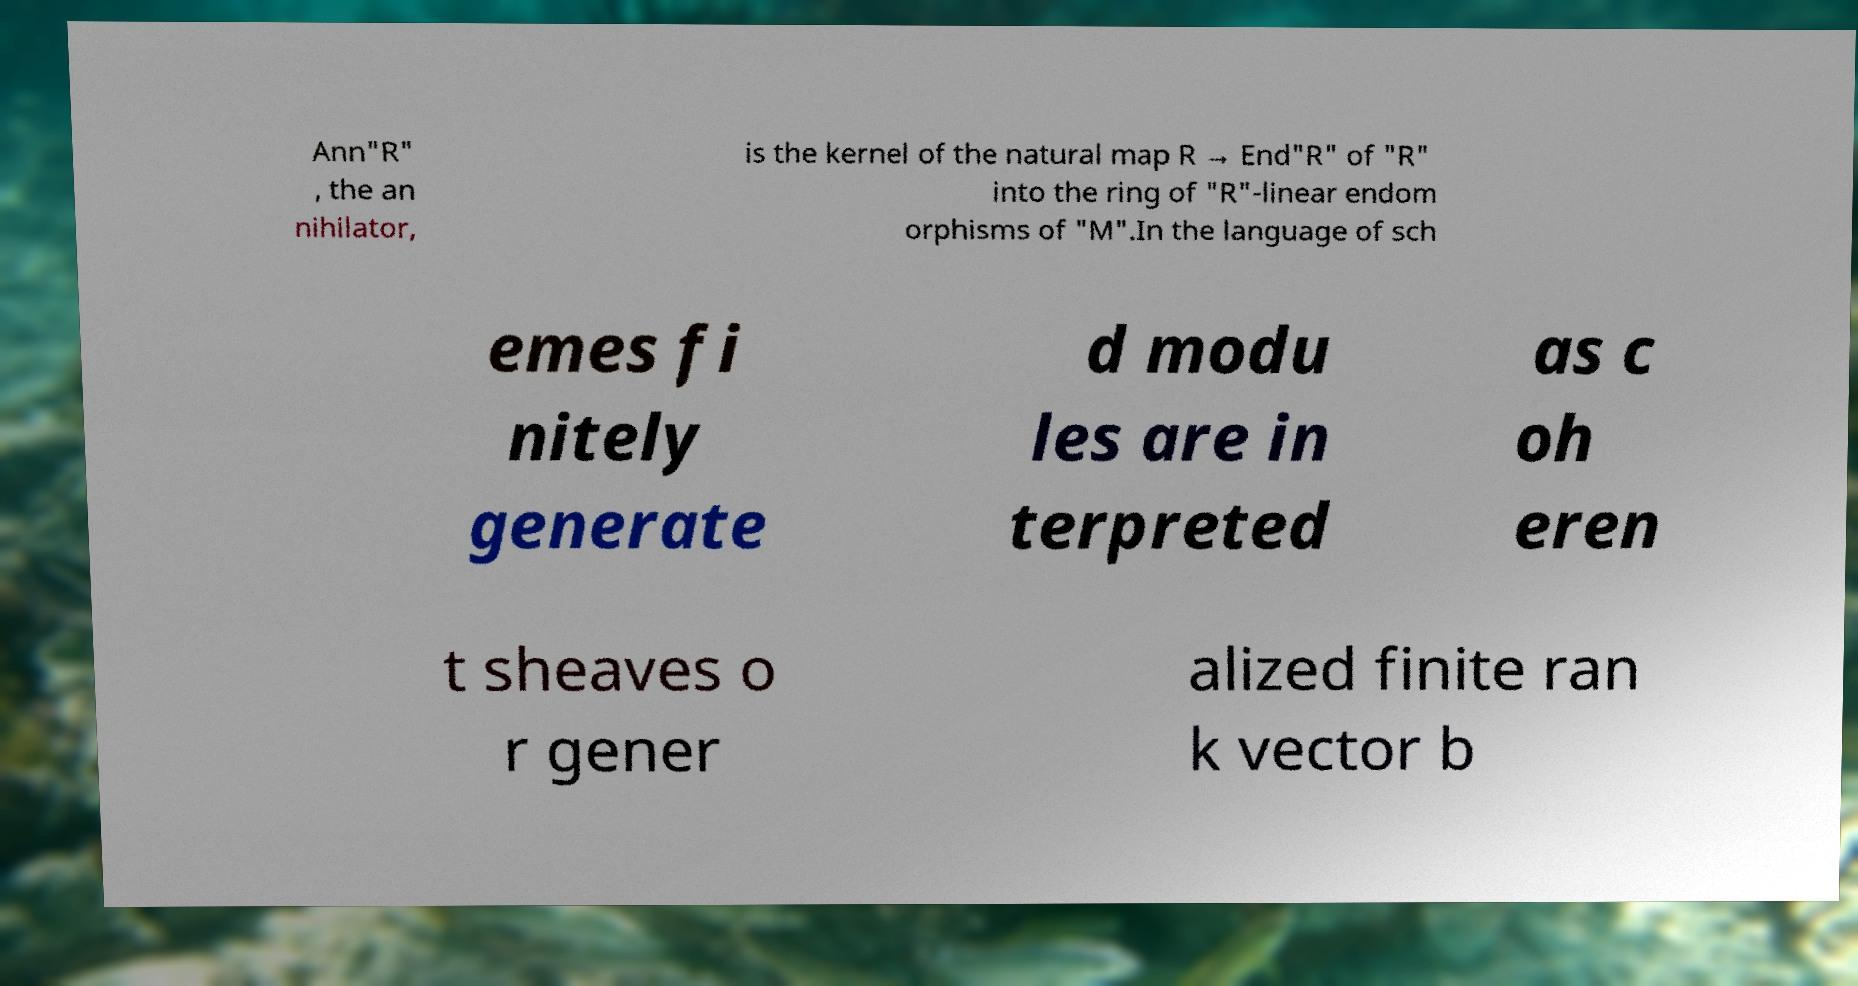Could you extract and type out the text from this image? Ann"R" , the an nihilator, is the kernel of the natural map R → End"R" of "R" into the ring of "R"-linear endom orphisms of "M".In the language of sch emes fi nitely generate d modu les are in terpreted as c oh eren t sheaves o r gener alized finite ran k vector b 